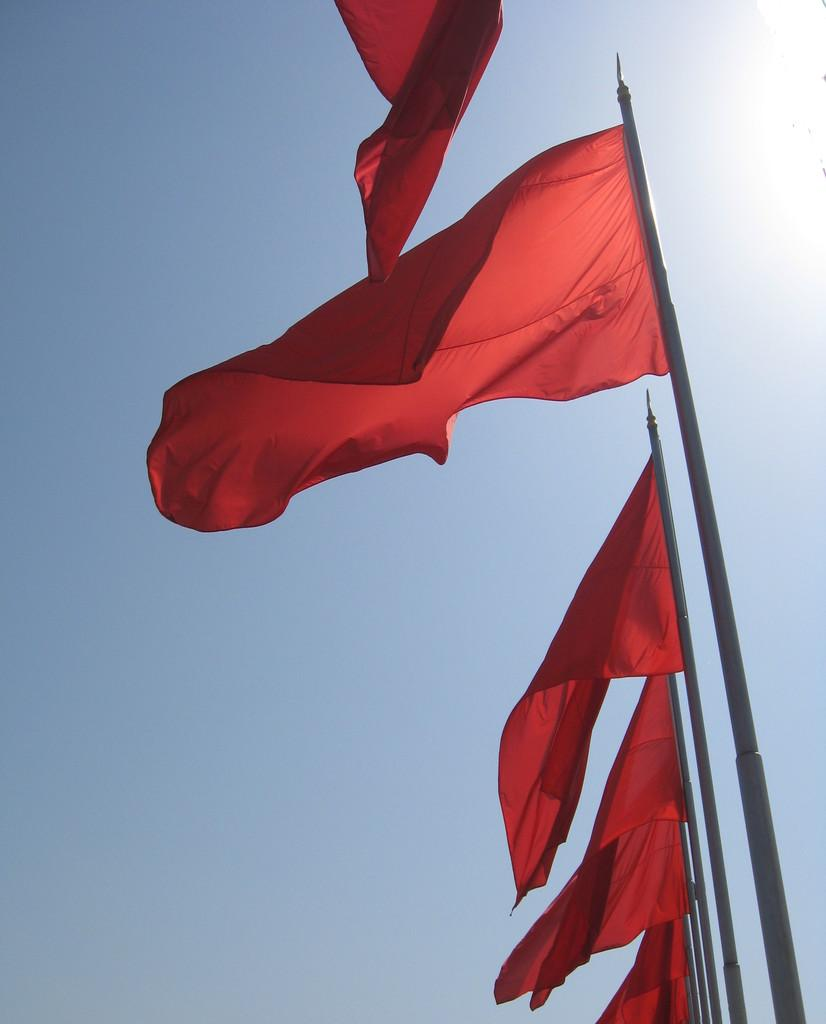What type of flags are present in the image? There are red color flags in the image. How are the flags supported or held up? The flags are attached to poles. What can be seen in the background of the image? The sky is visible in the image. What is the color of the sky in the image? The color of the sky is blue. What type of sweater is being worn by the brick in the image? There is no sweater or brick present in the image; it features red color flags and a blue sky. 